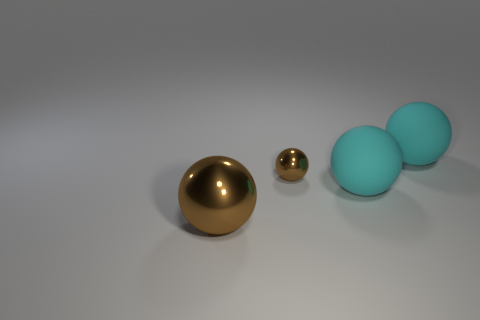Does the big cyan sphere that is behind the tiny thing have the same material as the large brown object?
Offer a terse response. No. Is there another small object of the same shape as the tiny brown metal object?
Make the answer very short. No. Is the number of metal things that are behind the tiny shiny sphere the same as the number of big cyan matte spheres?
Provide a short and direct response. No. What material is the brown ball in front of the big cyan matte sphere in front of the small brown shiny sphere?
Your answer should be very brief. Metal. The tiny brown object has what shape?
Make the answer very short. Sphere. Is the number of brown balls that are in front of the large brown metal ball the same as the number of tiny things that are in front of the tiny brown sphere?
Ensure brevity in your answer.  Yes. There is a metallic ball right of the big brown metallic object; is it the same color as the big sphere behind the small object?
Offer a very short reply. No. Are there more small spheres that are to the left of the large brown sphere than big metallic spheres?
Keep it short and to the point. No. The tiny brown object that is made of the same material as the big brown sphere is what shape?
Your response must be concise. Sphere. There is a matte thing left of the thing that is behind the small brown metal thing; what is its shape?
Your response must be concise. Sphere. 